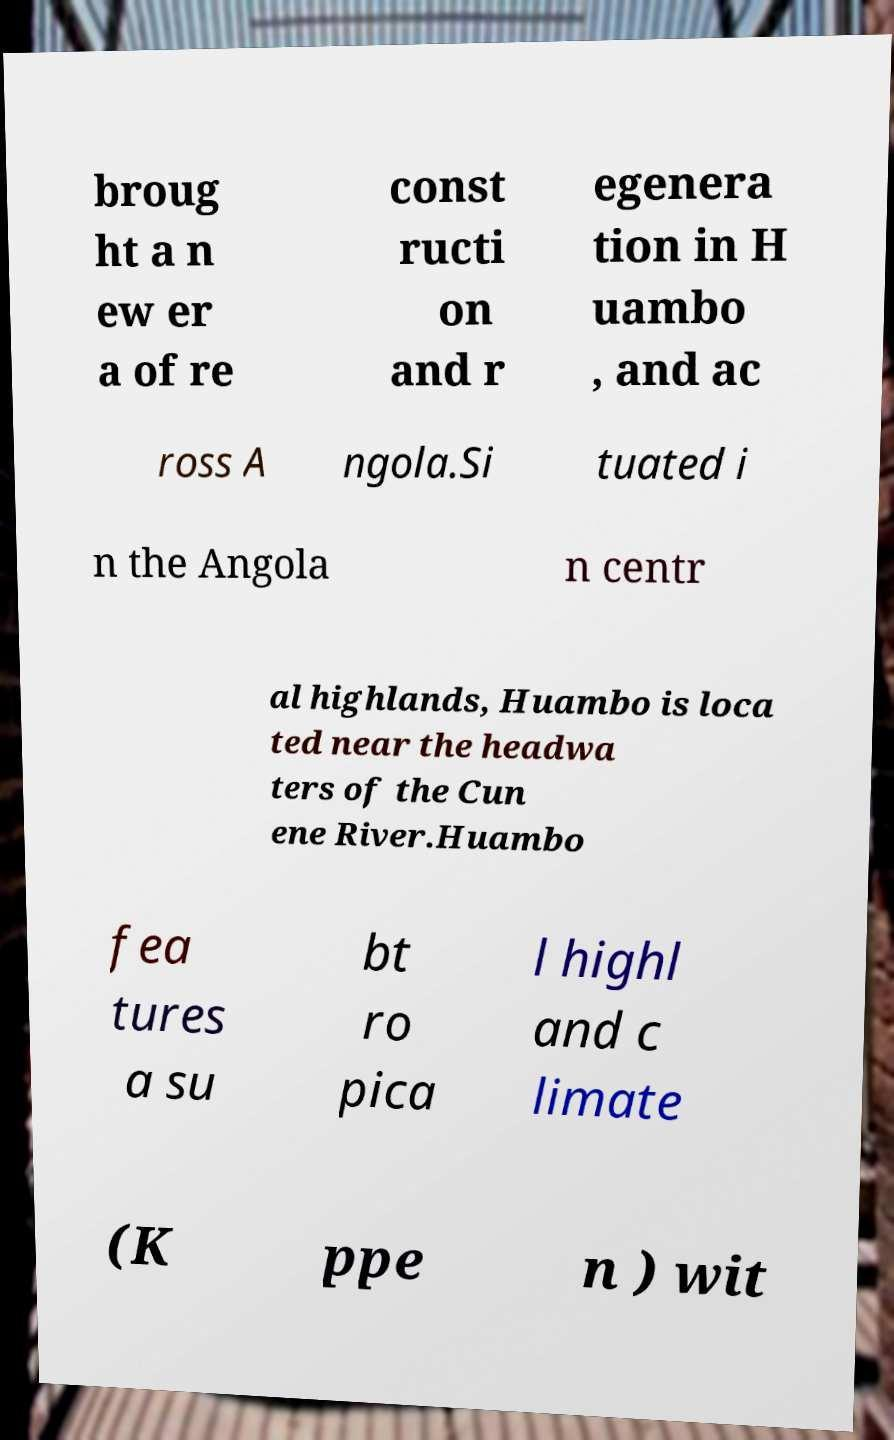I need the written content from this picture converted into text. Can you do that? broug ht a n ew er a of re const ructi on and r egenera tion in H uambo , and ac ross A ngola.Si tuated i n the Angola n centr al highlands, Huambo is loca ted near the headwa ters of the Cun ene River.Huambo fea tures a su bt ro pica l highl and c limate (K ppe n ) wit 